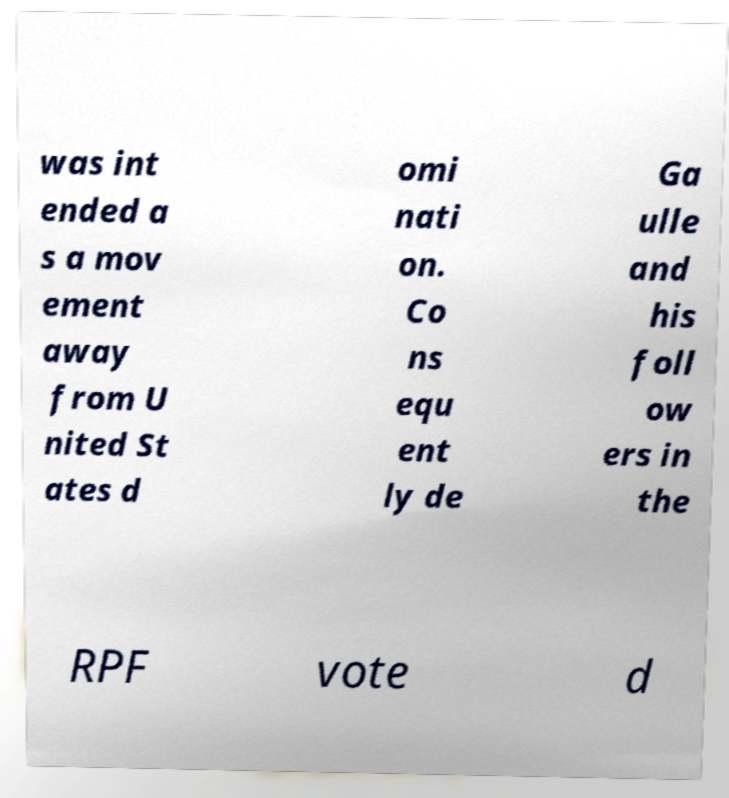What messages or text are displayed in this image? I need them in a readable, typed format. was int ended a s a mov ement away from U nited St ates d omi nati on. Co ns equ ent ly de Ga ulle and his foll ow ers in the RPF vote d 